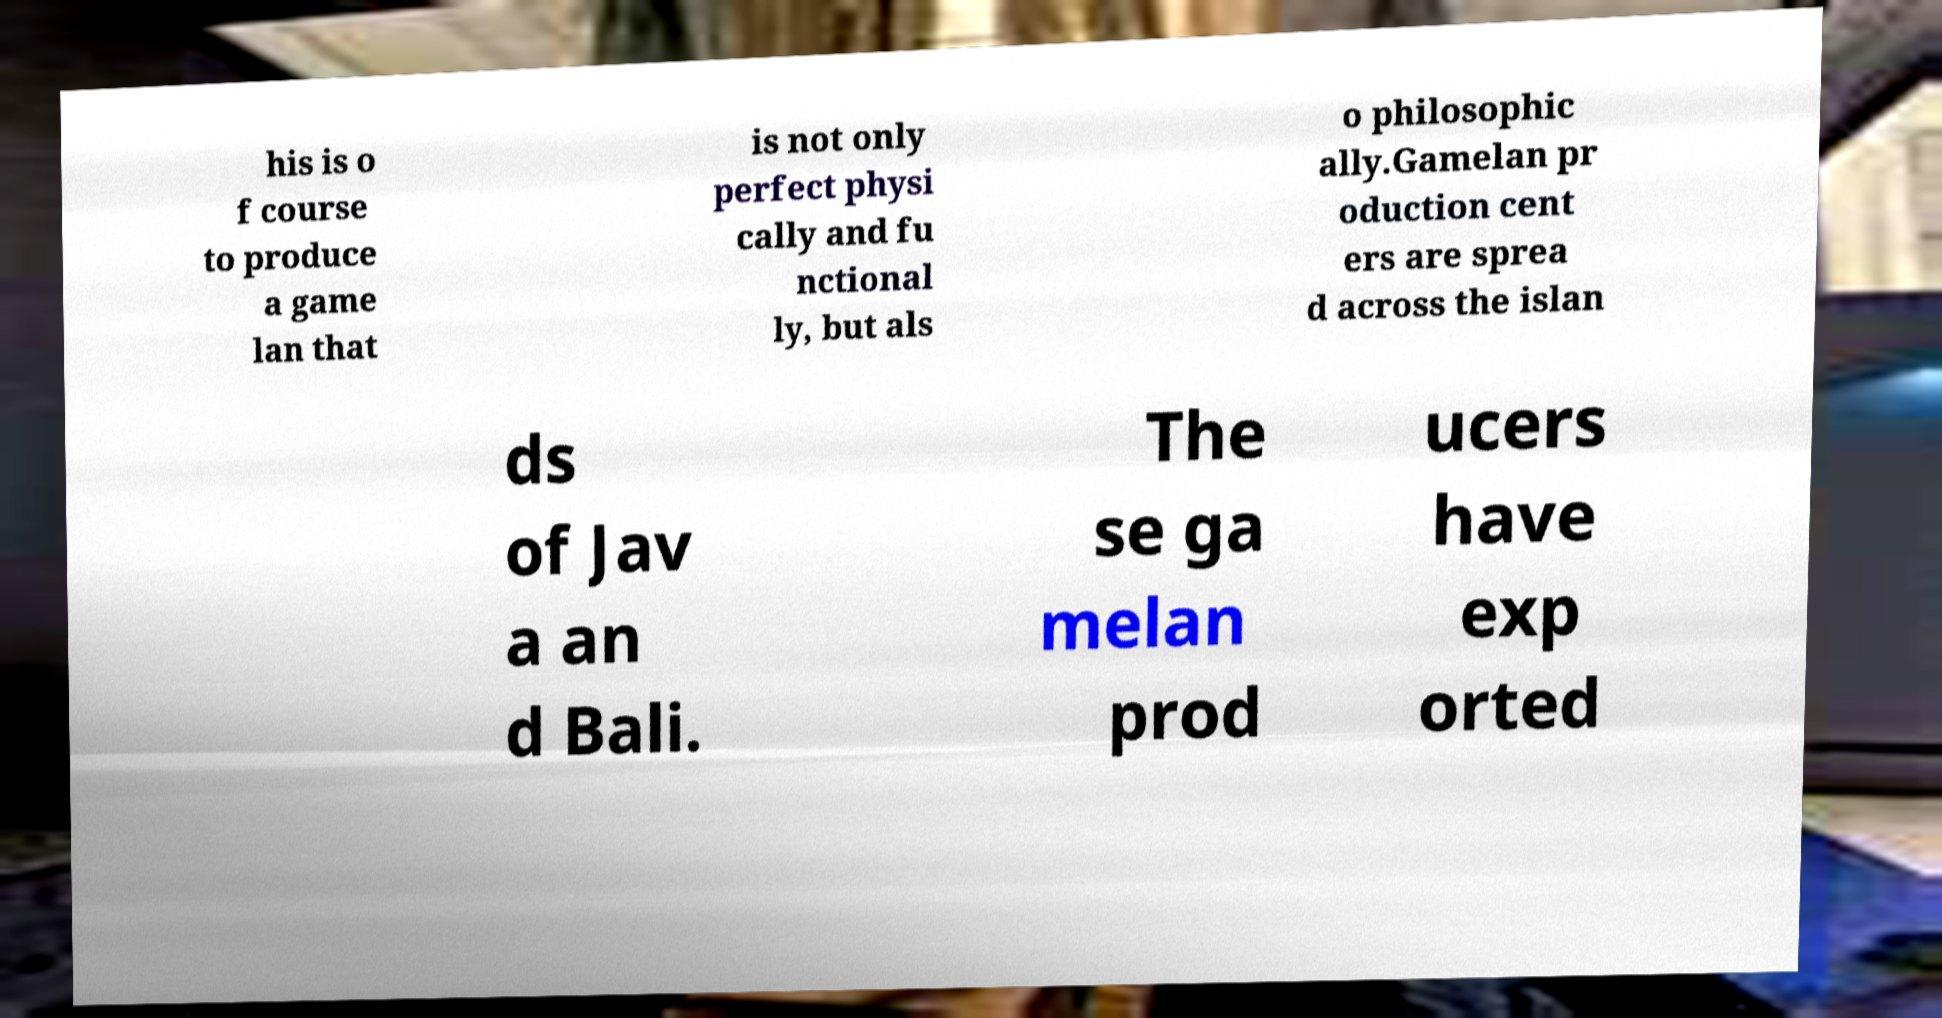I need the written content from this picture converted into text. Can you do that? his is o f course to produce a game lan that is not only perfect physi cally and fu nctional ly, but als o philosophic ally.Gamelan pr oduction cent ers are sprea d across the islan ds of Jav a an d Bali. The se ga melan prod ucers have exp orted 